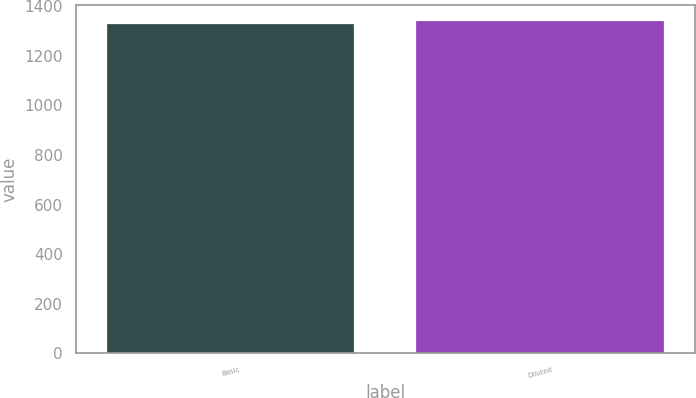<chart> <loc_0><loc_0><loc_500><loc_500><bar_chart><fcel>Basic<fcel>Diluted<nl><fcel>1330<fcel>1339<nl></chart> 